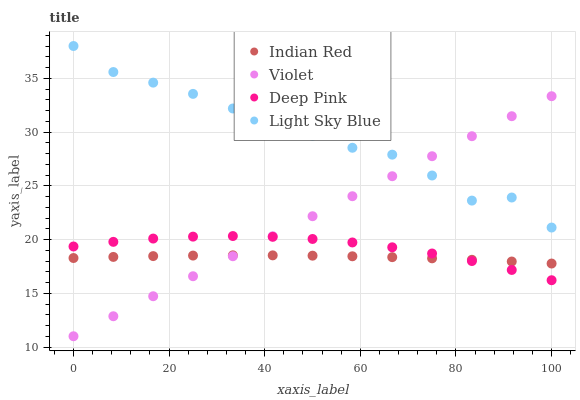Does Indian Red have the minimum area under the curve?
Answer yes or no. Yes. Does Light Sky Blue have the maximum area under the curve?
Answer yes or no. Yes. Does Deep Pink have the minimum area under the curve?
Answer yes or no. No. Does Deep Pink have the maximum area under the curve?
Answer yes or no. No. Is Violet the smoothest?
Answer yes or no. Yes. Is Light Sky Blue the roughest?
Answer yes or no. Yes. Is Deep Pink the smoothest?
Answer yes or no. No. Is Deep Pink the roughest?
Answer yes or no. No. Does Violet have the lowest value?
Answer yes or no. Yes. Does Deep Pink have the lowest value?
Answer yes or no. No. Does Light Sky Blue have the highest value?
Answer yes or no. Yes. Does Deep Pink have the highest value?
Answer yes or no. No. Is Indian Red less than Light Sky Blue?
Answer yes or no. Yes. Is Light Sky Blue greater than Deep Pink?
Answer yes or no. Yes. Does Light Sky Blue intersect Violet?
Answer yes or no. Yes. Is Light Sky Blue less than Violet?
Answer yes or no. No. Is Light Sky Blue greater than Violet?
Answer yes or no. No. Does Indian Red intersect Light Sky Blue?
Answer yes or no. No. 